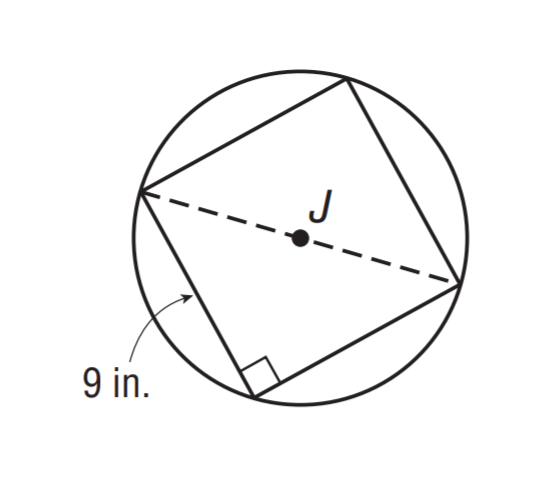Answer the mathemtical geometry problem and directly provide the correct option letter.
Question: A square with side length of 9 inches is inscribed in \odot J. Find the exact circumference of \odot J.
Choices: A: 8 \sqrt 2 \pi B: 9 \sqrt 2 \pi C: 12 \sqrt 2 \pi D: 15 \sqrt 2 \pi B 